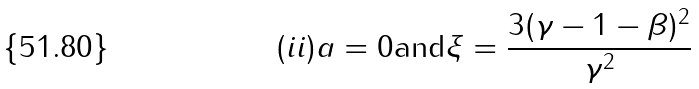Convert formula to latex. <formula><loc_0><loc_0><loc_500><loc_500>( i i ) a = 0 \text {and} \xi = \frac { 3 ( \gamma - 1 - \beta ) ^ { 2 } } { \gamma ^ { 2 } }</formula> 